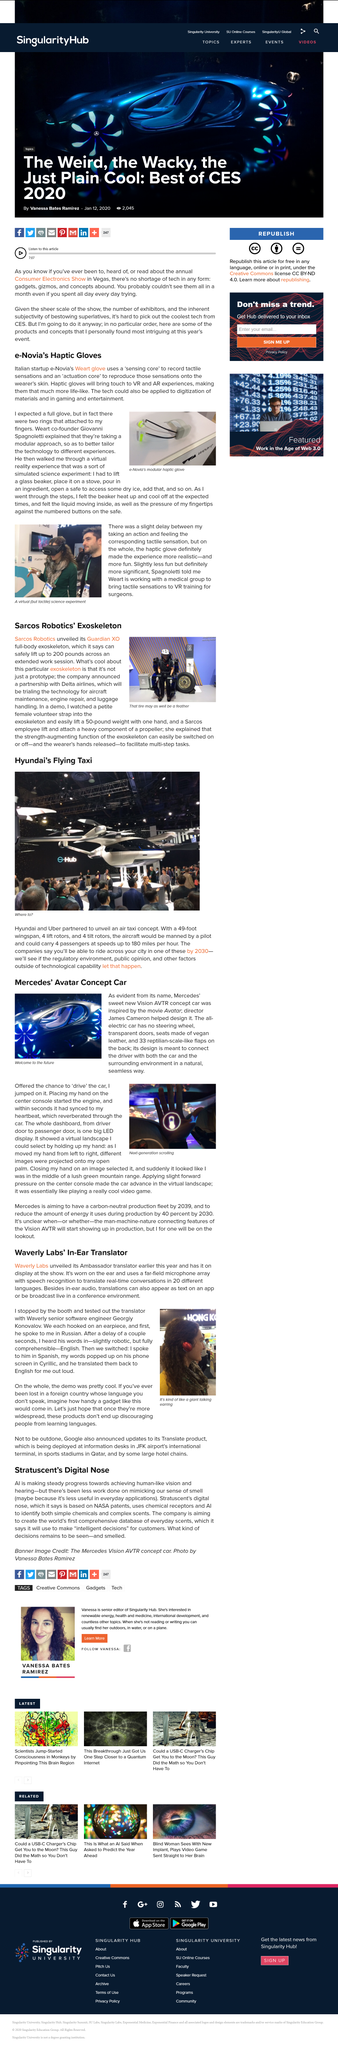Highlight a few significant elements in this photo. e-Novia was developed in Italy, a country known for its innovative technology and creative spirit. HOW MANY LANGUAGES CAN IT TRANSLATE? 20 LANGUAGES OR MORE. Georgiy Konovalov is a senior software engineer at Waverly, who is known for his exceptional work ethic and technical expertise. Waverly Labs unveiled its Ambassador translator, which allows for seamless communication in multiple languages. The color primarily used in the image captioned "Welcome to the future?" is blue, and the color primarily used in the image captioned "Welcome to the future" is also blue. 